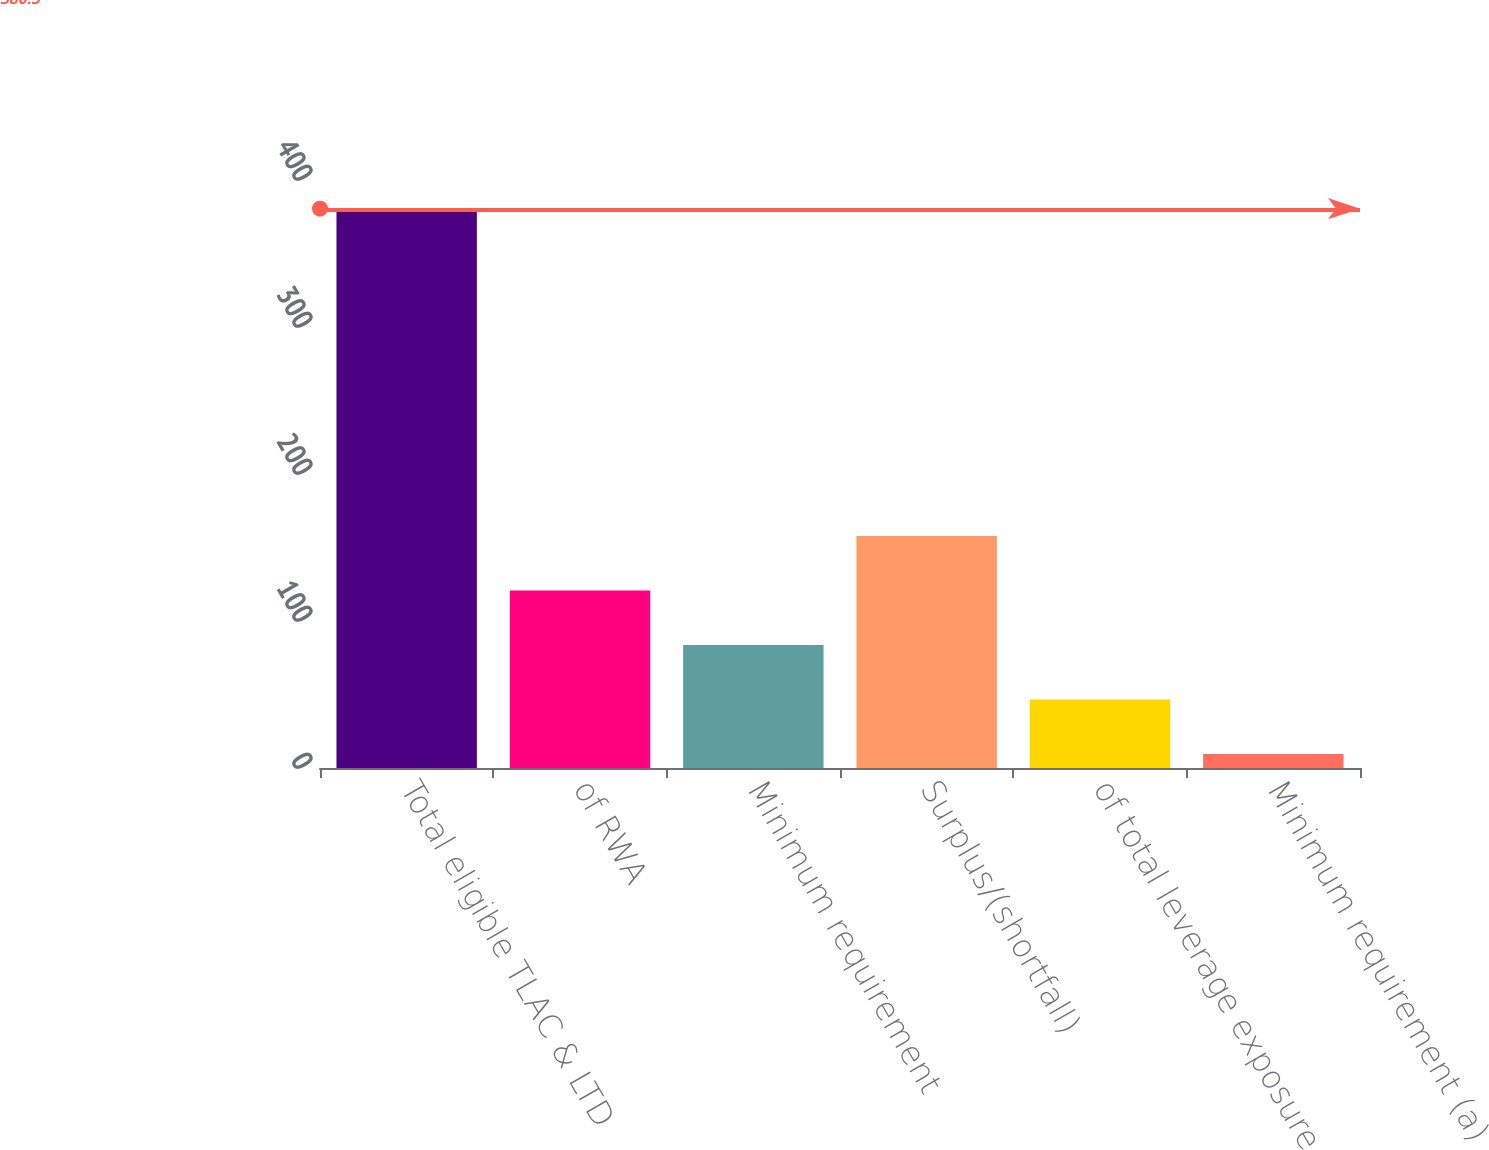Convert chart to OTSL. <chart><loc_0><loc_0><loc_500><loc_500><bar_chart><fcel>Total eligible TLAC & LTD<fcel>of RWA<fcel>Minimum requirement<fcel>Surplus/(shortfall)<fcel>of total leverage exposure<fcel>Minimum requirement (a)<nl><fcel>380.5<fcel>120.8<fcel>83.7<fcel>157.9<fcel>46.6<fcel>9.5<nl></chart> 